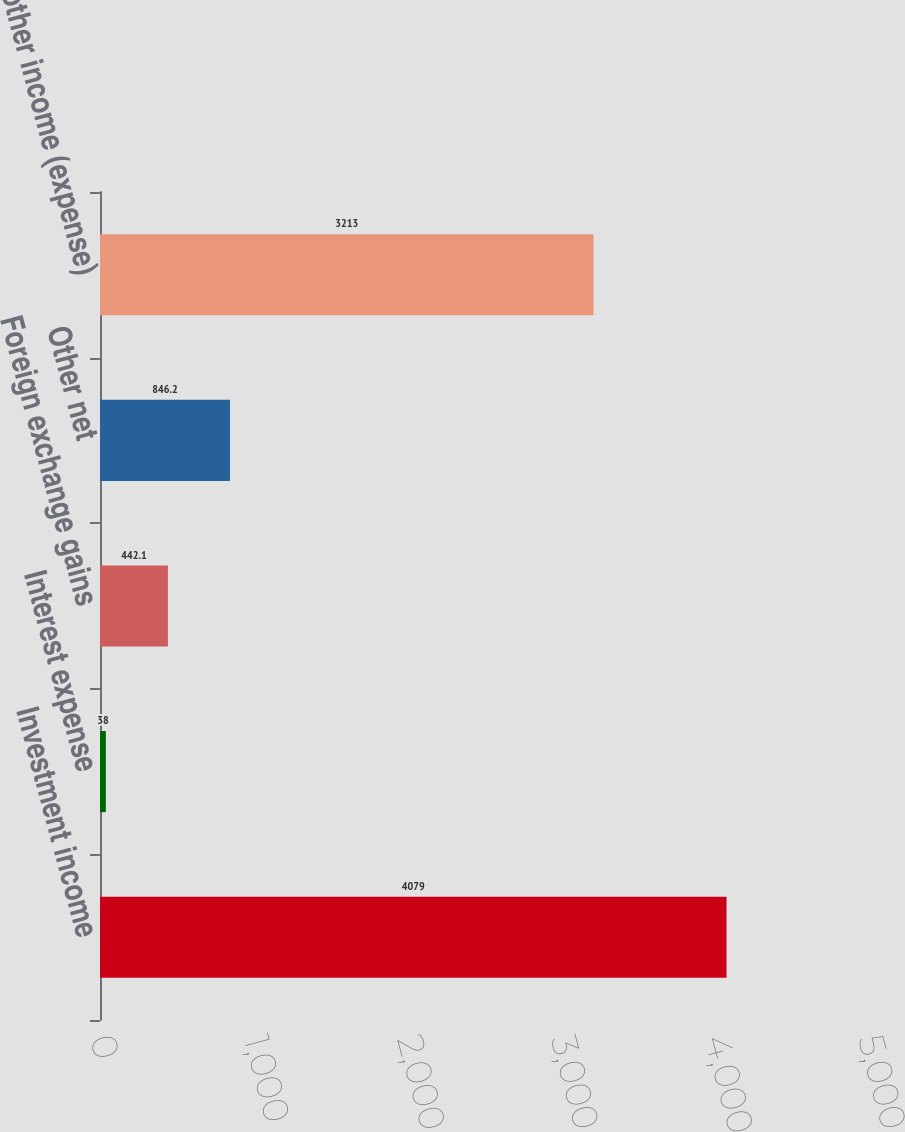Convert chart. <chart><loc_0><loc_0><loc_500><loc_500><bar_chart><fcel>Investment income<fcel>Interest expense<fcel>Foreign exchange gains<fcel>Other net<fcel>Total other income (expense)<nl><fcel>4079<fcel>38<fcel>442.1<fcel>846.2<fcel>3213<nl></chart> 